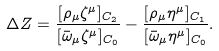<formula> <loc_0><loc_0><loc_500><loc_500>\Delta Z = \frac { [ \rho _ { \mu } \zeta ^ { \mu } ] _ { C _ { 2 } } } { [ \bar { \omega } _ { \mu } \zeta ^ { \mu } ] _ { C _ { 0 } } } - \frac { [ \rho _ { \mu } \eta ^ { \mu } ] _ { C _ { 1 } } } { [ \bar { \omega } _ { \mu } \eta ^ { \mu } ] _ { C _ { 0 } } } .</formula> 